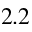<formula> <loc_0><loc_0><loc_500><loc_500>2 . 2</formula> 